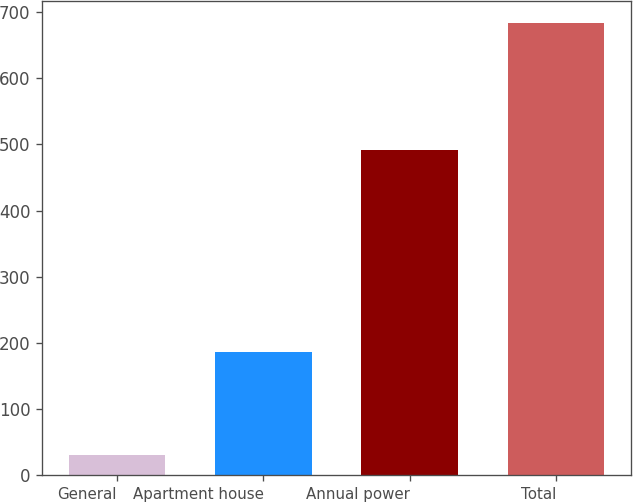Convert chart. <chart><loc_0><loc_0><loc_500><loc_500><bar_chart><fcel>General<fcel>Apartment house<fcel>Annual power<fcel>Total<nl><fcel>31<fcel>187<fcel>491<fcel>683<nl></chart> 